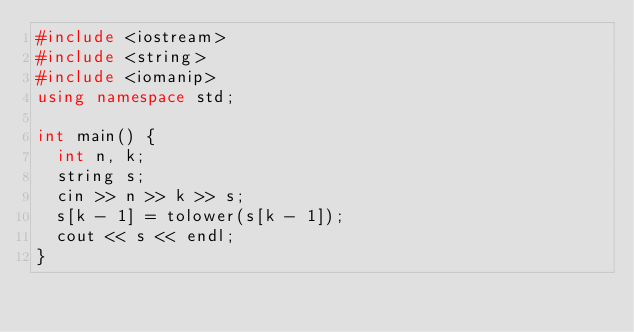<code> <loc_0><loc_0><loc_500><loc_500><_C++_>#include <iostream>
#include <string>
#include <iomanip>
using namespace std;

int main() {
  int n, k;
  string s;
  cin >> n >> k >> s;
  s[k - 1] = tolower(s[k - 1]);
  cout << s << endl;
}</code> 